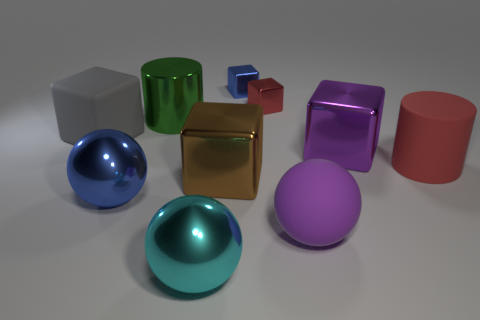There is a thing that is the same color as the matte ball; what is it made of?
Ensure brevity in your answer.  Metal. What number of other objects are there of the same material as the big red cylinder?
Your response must be concise. 2. How many tiny brown metallic blocks are there?
Your answer should be compact. 0. How many things are tiny blue metal blocks or cylinders that are in front of the big green object?
Keep it short and to the point. 2. There is a gray block that is to the left of the matte cylinder; is it the same size as the large brown cube?
Your answer should be very brief. Yes. What number of metal objects are either tiny cubes or small cyan cylinders?
Your answer should be compact. 2. There is a red cylinder behind the purple rubber sphere; how big is it?
Ensure brevity in your answer.  Large. Is the large purple matte object the same shape as the big blue shiny thing?
Offer a terse response. Yes. What number of large things are either balls or shiny spheres?
Your answer should be compact. 3. There is a red matte object; are there any large shiny objects behind it?
Ensure brevity in your answer.  Yes. 